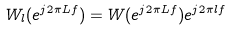<formula> <loc_0><loc_0><loc_500><loc_500>W _ { l } ( e ^ { j 2 \pi L f } ) & = W ( e ^ { j 2 \pi L f } ) e ^ { j 2 \pi l f }</formula> 